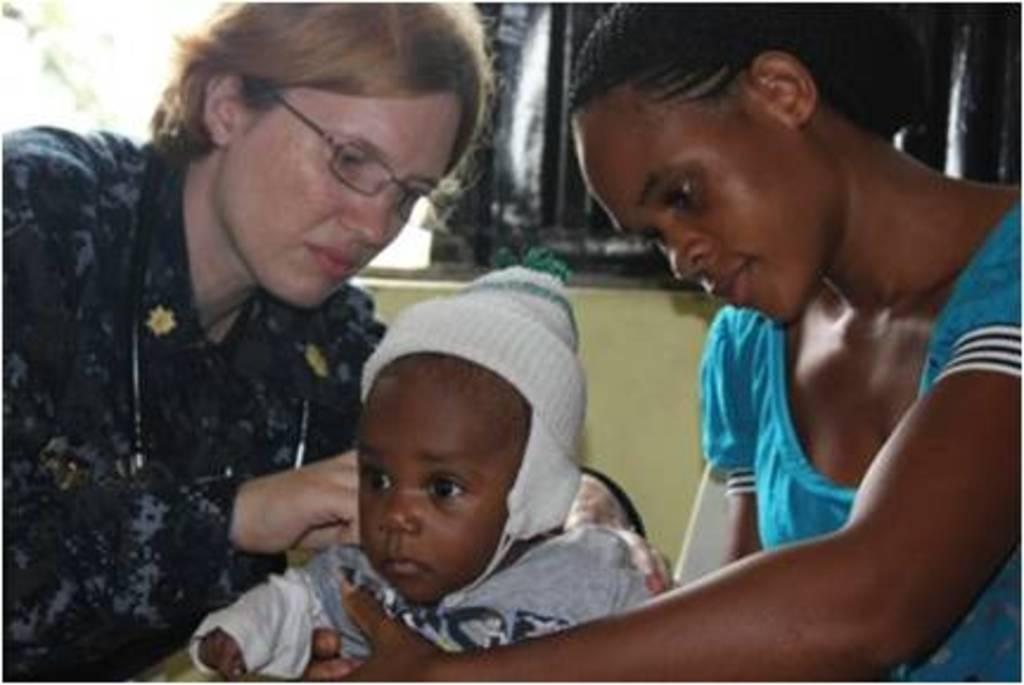How many people are in the image? There are persons in the image. Can you describe the age of one of the individuals in the image? There is a kid in the image. What are the persons and the kid wearing? The persons and the kid are wearing clothes. What architectural feature can be seen in the top left of the image? There is a window in the top left of the image. How many beans are on the plate in the image? There is no plate or beans present in the image. What type of girl is sitting on the floor in the image? There is no girl sitting on the floor in the image. 